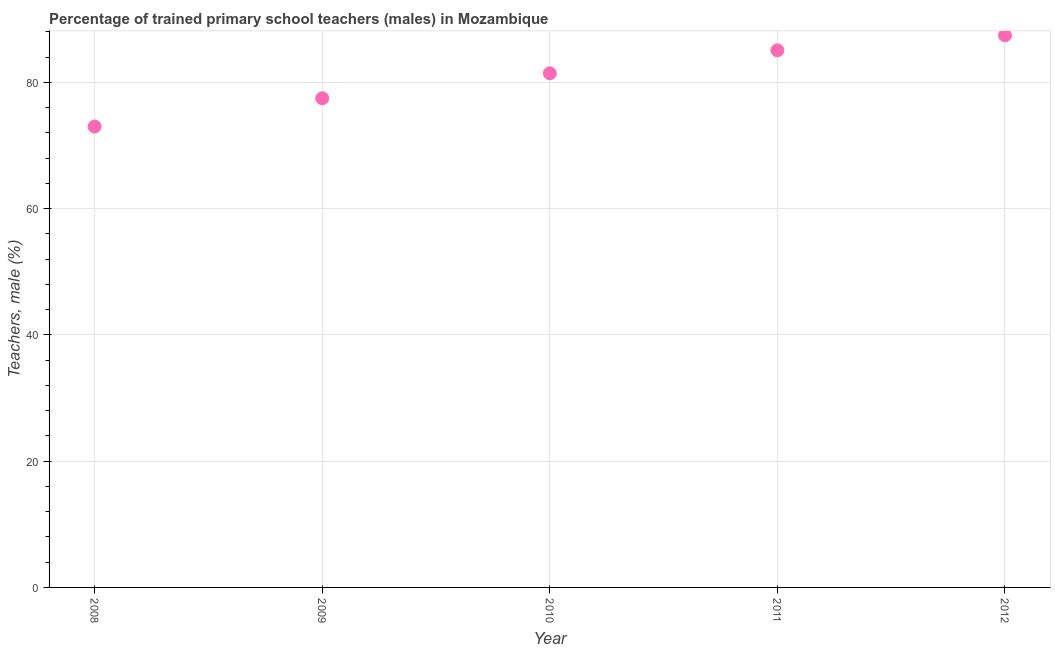What is the percentage of trained male teachers in 2008?
Offer a very short reply. 73.01. Across all years, what is the maximum percentage of trained male teachers?
Your answer should be compact. 87.46. Across all years, what is the minimum percentage of trained male teachers?
Give a very brief answer. 73.01. In which year was the percentage of trained male teachers maximum?
Make the answer very short. 2012. What is the sum of the percentage of trained male teachers?
Keep it short and to the point. 404.53. What is the difference between the percentage of trained male teachers in 2009 and 2012?
Your answer should be compact. -9.97. What is the average percentage of trained male teachers per year?
Ensure brevity in your answer.  80.91. What is the median percentage of trained male teachers?
Your answer should be compact. 81.46. What is the ratio of the percentage of trained male teachers in 2009 to that in 2012?
Offer a very short reply. 0.89. Is the percentage of trained male teachers in 2009 less than that in 2012?
Keep it short and to the point. Yes. What is the difference between the highest and the second highest percentage of trained male teachers?
Your answer should be compact. 2.36. What is the difference between the highest and the lowest percentage of trained male teachers?
Your response must be concise. 14.45. In how many years, is the percentage of trained male teachers greater than the average percentage of trained male teachers taken over all years?
Your answer should be compact. 3. Does the percentage of trained male teachers monotonically increase over the years?
Provide a short and direct response. Yes. What is the difference between two consecutive major ticks on the Y-axis?
Provide a succinct answer. 20. Does the graph contain grids?
Your response must be concise. Yes. What is the title of the graph?
Make the answer very short. Percentage of trained primary school teachers (males) in Mozambique. What is the label or title of the Y-axis?
Give a very brief answer. Teachers, male (%). What is the Teachers, male (%) in 2008?
Make the answer very short. 73.01. What is the Teachers, male (%) in 2009?
Give a very brief answer. 77.5. What is the Teachers, male (%) in 2010?
Your answer should be compact. 81.46. What is the Teachers, male (%) in 2011?
Offer a terse response. 85.1. What is the Teachers, male (%) in 2012?
Offer a terse response. 87.46. What is the difference between the Teachers, male (%) in 2008 and 2009?
Provide a short and direct response. -4.48. What is the difference between the Teachers, male (%) in 2008 and 2010?
Provide a succinct answer. -8.44. What is the difference between the Teachers, male (%) in 2008 and 2011?
Your answer should be compact. -12.08. What is the difference between the Teachers, male (%) in 2008 and 2012?
Your answer should be compact. -14.45. What is the difference between the Teachers, male (%) in 2009 and 2010?
Provide a short and direct response. -3.96. What is the difference between the Teachers, male (%) in 2009 and 2011?
Ensure brevity in your answer.  -7.6. What is the difference between the Teachers, male (%) in 2009 and 2012?
Provide a succinct answer. -9.97. What is the difference between the Teachers, male (%) in 2010 and 2011?
Ensure brevity in your answer.  -3.64. What is the difference between the Teachers, male (%) in 2010 and 2012?
Give a very brief answer. -6. What is the difference between the Teachers, male (%) in 2011 and 2012?
Give a very brief answer. -2.36. What is the ratio of the Teachers, male (%) in 2008 to that in 2009?
Make the answer very short. 0.94. What is the ratio of the Teachers, male (%) in 2008 to that in 2010?
Keep it short and to the point. 0.9. What is the ratio of the Teachers, male (%) in 2008 to that in 2011?
Offer a terse response. 0.86. What is the ratio of the Teachers, male (%) in 2008 to that in 2012?
Make the answer very short. 0.83. What is the ratio of the Teachers, male (%) in 2009 to that in 2010?
Offer a very short reply. 0.95. What is the ratio of the Teachers, male (%) in 2009 to that in 2011?
Provide a succinct answer. 0.91. What is the ratio of the Teachers, male (%) in 2009 to that in 2012?
Offer a very short reply. 0.89. 